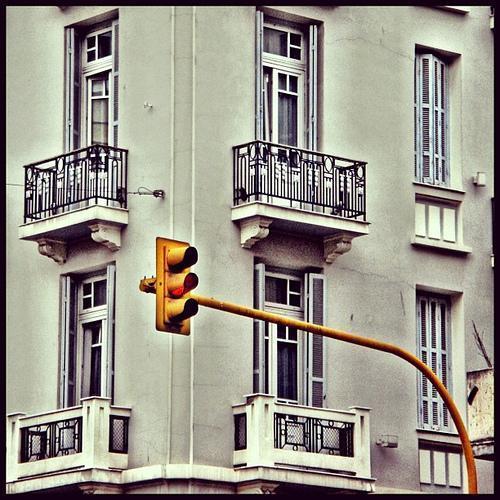How many windows are pictured?
Give a very brief answer. 6. How many balconies are pictured?
Give a very brief answer. 4. 